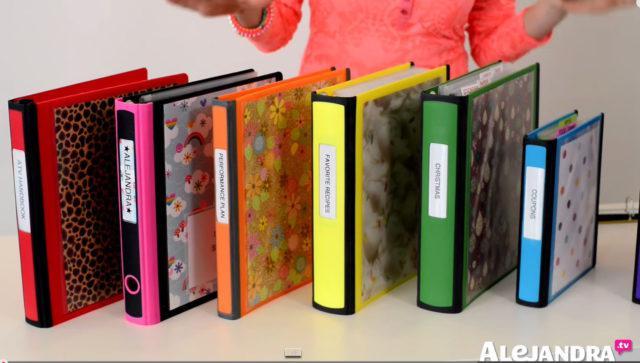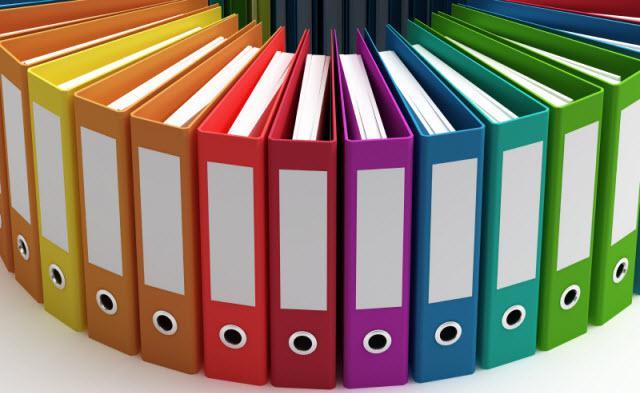The first image is the image on the left, the second image is the image on the right. Given the left and right images, does the statement "there are no more than four binders in the image on the right" hold true? Answer yes or no. No. 